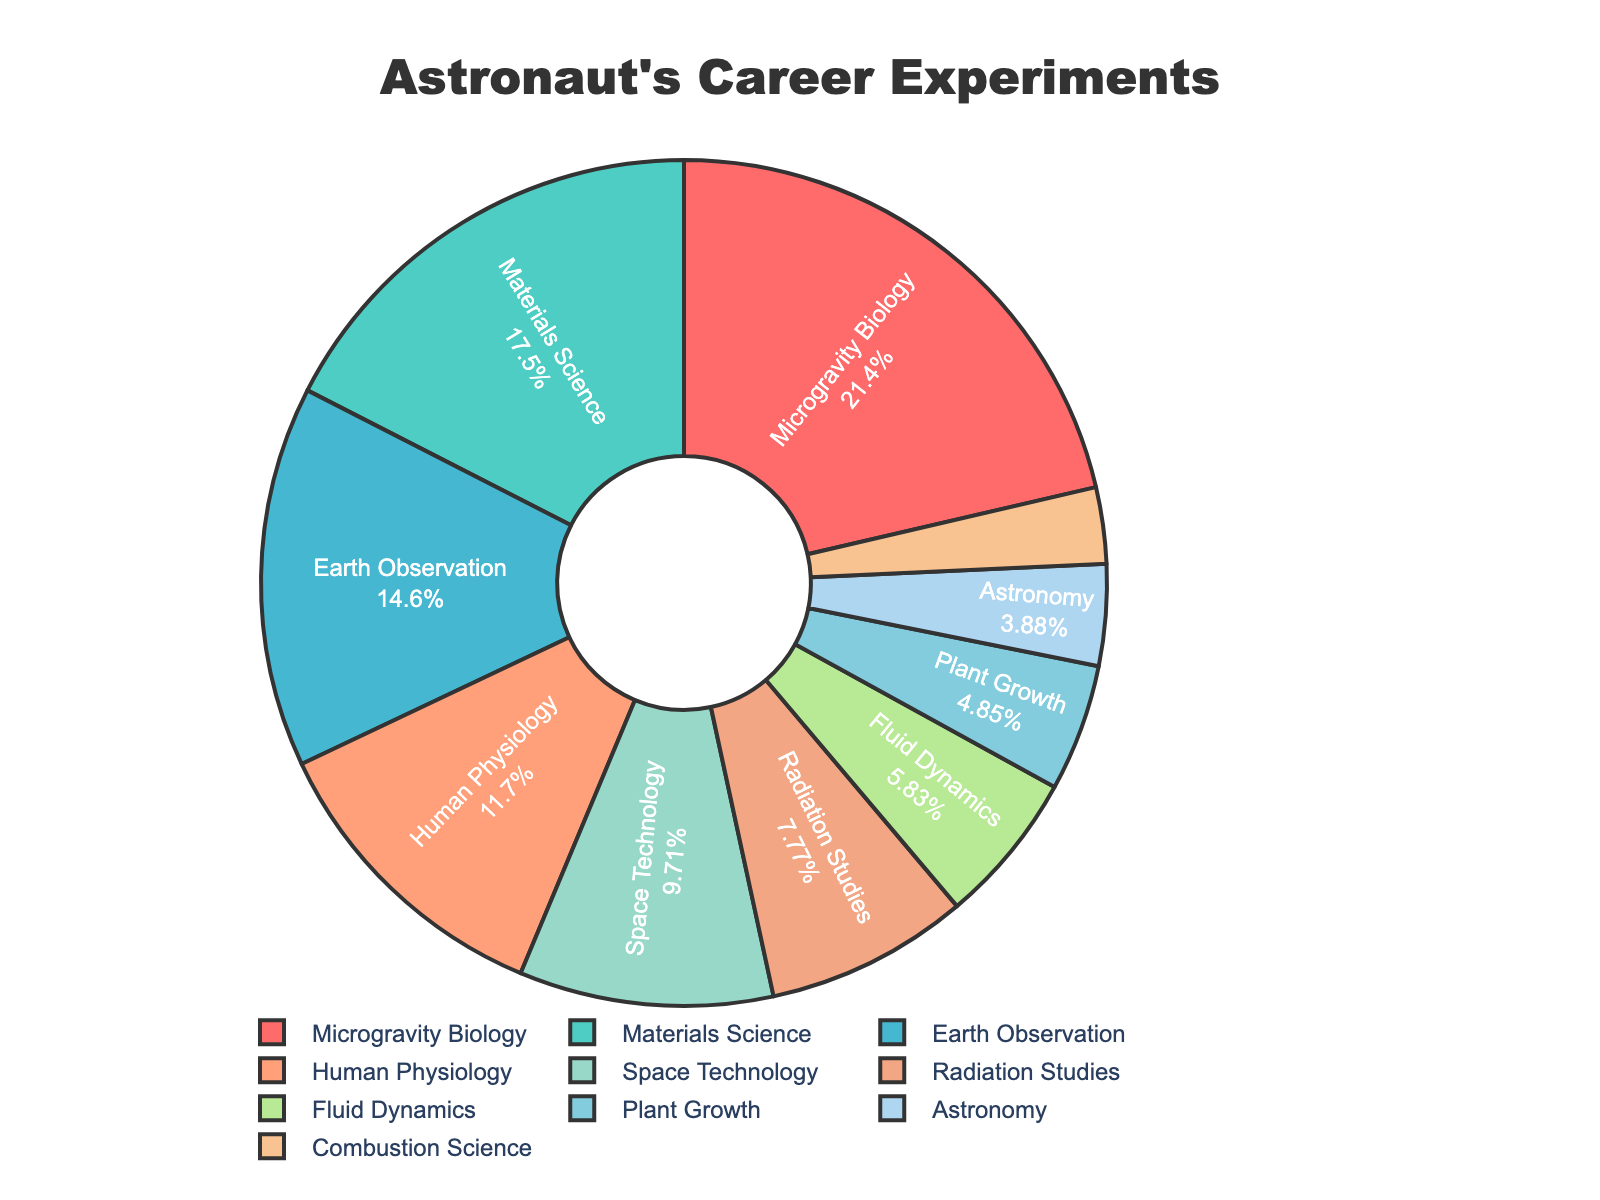What percentage of the experiments were related to Earth Observation and Human Physiology combined? To find the combined percentage of Earth Observation and Human Physiology experiments, add the percentages for both categories from the pie chart. Earth Observation accounts for 15% and Human Physiology for 12%. Therefore, 15% + 12% = 27%.
Answer: 27% Which experiment type had the highest proportion, and what percentage was it? The experiment type with the highest proportion can be identified by looking at the segment with the largest size on the pie chart. Microgravity Biology is the largest segment, accounting for 22% of the total experiments.
Answer: Microgravity Biology, 22% Which experiment had a lower percentage: Astronomy or Plant Growth? By comparing the percentages for Astronomy and Plant Growth on the chart, we see that Astronomy accounts for 4%, and Plant Growth accounts for 5%. Therefore, Astronomy has a lower percentage than Plant Growth.
Answer: Astronomy What is the proportion difference between Materials Science and Combustion Science experiments? To find the difference in proportion between two experiment types, subtract the percentage of the smaller category from the larger one. Materials Science accounts for 18%, and Combustion Science accounts for 3%. Therefore, 18% - 3% = 15%.
Answer: 15% How many experiment types have a percentage below 10%? Count the number of segments on the pie chart that represent less than 10% each. Radiation Studies (8%), Fluid Dynamics (6%), Plant Growth (5%), Astronomy (4%), and Combustion Science (3%) are all below 10%. Therefore, there are 5 experiment types below 10%.
Answer: 5 If you were to combine the proportions of Space Technology and Radiation Studies, would their total be greater than Microgravity Biology? Add the percentages of Space Technology (10%) and Radiation Studies (8%), which equals 18%. Microgravity Biology is 22%. Since 18% is less than 22%, the combined proportion is not greater than Microgravity Biology.
Answer: No Which experiment type forms the smallest segment, and what is its percentage? The smallest segment on the pie chart represents the experiment type with the lowest percentage. Combustion Science is the smallest segment, accounting for 3% of the total experiments.
Answer: Combustion Science, 3% What is the percentage of experiments not related to Earth Observation, Human Physiology, and Microgravity Biology combined? First, add percentages for Earth Observation (15%), Human Physiology (12%), and Microgravity Biology (22%), which equals 49%. Subtract this from 100% to find the remaining proportion: 100% - 49% = 51%.
Answer: 51% 